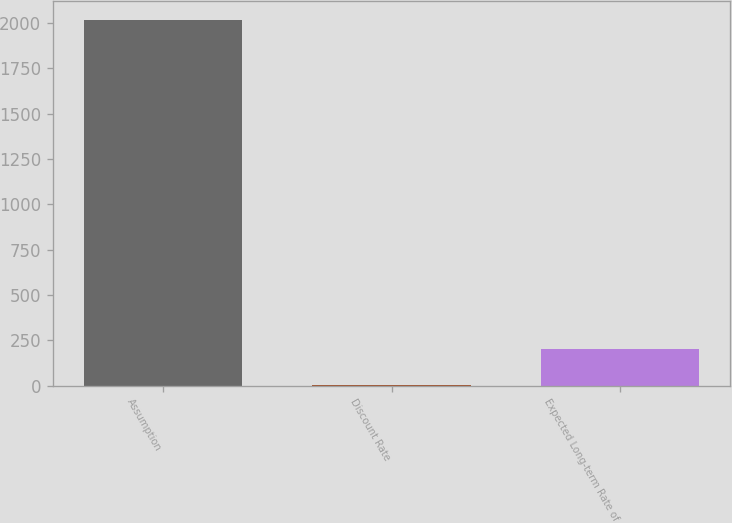Convert chart. <chart><loc_0><loc_0><loc_500><loc_500><bar_chart><fcel>Assumption<fcel>Discount Rate<fcel>Expected Long-term Rate of<nl><fcel>2018<fcel>2.5<fcel>204.05<nl></chart> 